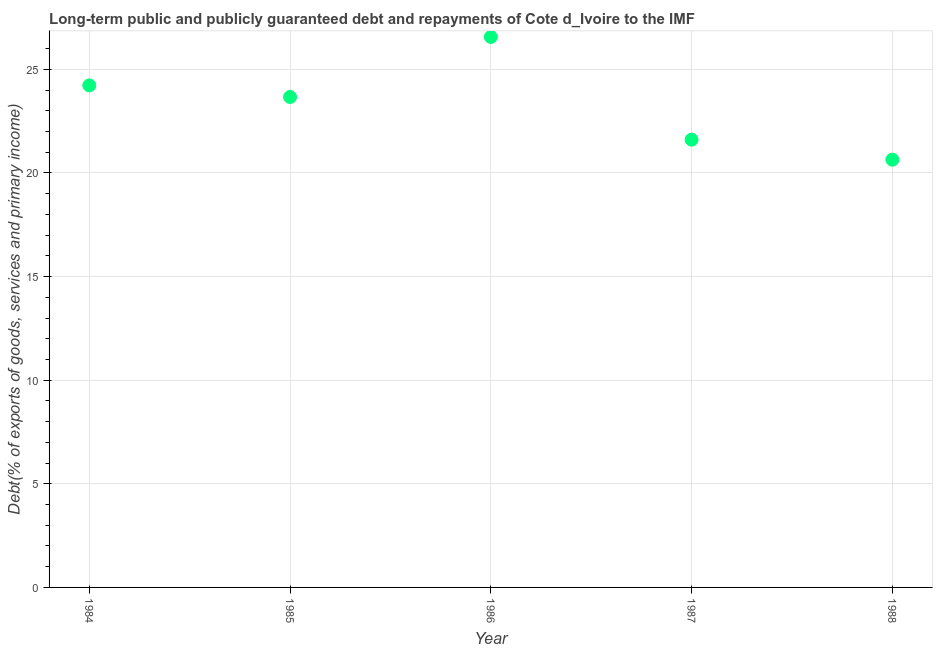What is the debt service in 1984?
Offer a terse response. 24.22. Across all years, what is the maximum debt service?
Your answer should be very brief. 26.56. Across all years, what is the minimum debt service?
Offer a very short reply. 20.64. What is the sum of the debt service?
Your response must be concise. 116.69. What is the difference between the debt service in 1984 and 1987?
Offer a terse response. 2.62. What is the average debt service per year?
Your response must be concise. 23.34. What is the median debt service?
Ensure brevity in your answer.  23.67. In how many years, is the debt service greater than 3 %?
Your response must be concise. 5. What is the ratio of the debt service in 1985 to that in 1988?
Offer a terse response. 1.15. Is the debt service in 1986 less than that in 1988?
Your answer should be compact. No. Is the difference between the debt service in 1985 and 1986 greater than the difference between any two years?
Offer a very short reply. No. What is the difference between the highest and the second highest debt service?
Offer a very short reply. 2.34. Is the sum of the debt service in 1984 and 1987 greater than the maximum debt service across all years?
Offer a terse response. Yes. What is the difference between the highest and the lowest debt service?
Ensure brevity in your answer.  5.92. Does the debt service monotonically increase over the years?
Offer a terse response. No. How many dotlines are there?
Offer a very short reply. 1. How many years are there in the graph?
Ensure brevity in your answer.  5. What is the difference between two consecutive major ticks on the Y-axis?
Keep it short and to the point. 5. Does the graph contain any zero values?
Your answer should be compact. No. Does the graph contain grids?
Your answer should be compact. Yes. What is the title of the graph?
Provide a succinct answer. Long-term public and publicly guaranteed debt and repayments of Cote d_Ivoire to the IMF. What is the label or title of the X-axis?
Your answer should be compact. Year. What is the label or title of the Y-axis?
Ensure brevity in your answer.  Debt(% of exports of goods, services and primary income). What is the Debt(% of exports of goods, services and primary income) in 1984?
Keep it short and to the point. 24.22. What is the Debt(% of exports of goods, services and primary income) in 1985?
Ensure brevity in your answer.  23.67. What is the Debt(% of exports of goods, services and primary income) in 1986?
Your response must be concise. 26.56. What is the Debt(% of exports of goods, services and primary income) in 1987?
Your response must be concise. 21.6. What is the Debt(% of exports of goods, services and primary income) in 1988?
Your answer should be compact. 20.64. What is the difference between the Debt(% of exports of goods, services and primary income) in 1984 and 1985?
Keep it short and to the point. 0.56. What is the difference between the Debt(% of exports of goods, services and primary income) in 1984 and 1986?
Provide a short and direct response. -2.34. What is the difference between the Debt(% of exports of goods, services and primary income) in 1984 and 1987?
Offer a very short reply. 2.62. What is the difference between the Debt(% of exports of goods, services and primary income) in 1984 and 1988?
Your response must be concise. 3.58. What is the difference between the Debt(% of exports of goods, services and primary income) in 1985 and 1986?
Provide a succinct answer. -2.9. What is the difference between the Debt(% of exports of goods, services and primary income) in 1985 and 1987?
Provide a short and direct response. 2.06. What is the difference between the Debt(% of exports of goods, services and primary income) in 1985 and 1988?
Your response must be concise. 3.03. What is the difference between the Debt(% of exports of goods, services and primary income) in 1986 and 1987?
Ensure brevity in your answer.  4.96. What is the difference between the Debt(% of exports of goods, services and primary income) in 1986 and 1988?
Offer a terse response. 5.92. What is the difference between the Debt(% of exports of goods, services and primary income) in 1987 and 1988?
Provide a short and direct response. 0.97. What is the ratio of the Debt(% of exports of goods, services and primary income) in 1984 to that in 1986?
Your response must be concise. 0.91. What is the ratio of the Debt(% of exports of goods, services and primary income) in 1984 to that in 1987?
Provide a short and direct response. 1.12. What is the ratio of the Debt(% of exports of goods, services and primary income) in 1984 to that in 1988?
Give a very brief answer. 1.17. What is the ratio of the Debt(% of exports of goods, services and primary income) in 1985 to that in 1986?
Your answer should be very brief. 0.89. What is the ratio of the Debt(% of exports of goods, services and primary income) in 1985 to that in 1987?
Provide a succinct answer. 1.09. What is the ratio of the Debt(% of exports of goods, services and primary income) in 1985 to that in 1988?
Provide a short and direct response. 1.15. What is the ratio of the Debt(% of exports of goods, services and primary income) in 1986 to that in 1987?
Keep it short and to the point. 1.23. What is the ratio of the Debt(% of exports of goods, services and primary income) in 1986 to that in 1988?
Make the answer very short. 1.29. What is the ratio of the Debt(% of exports of goods, services and primary income) in 1987 to that in 1988?
Your answer should be compact. 1.05. 